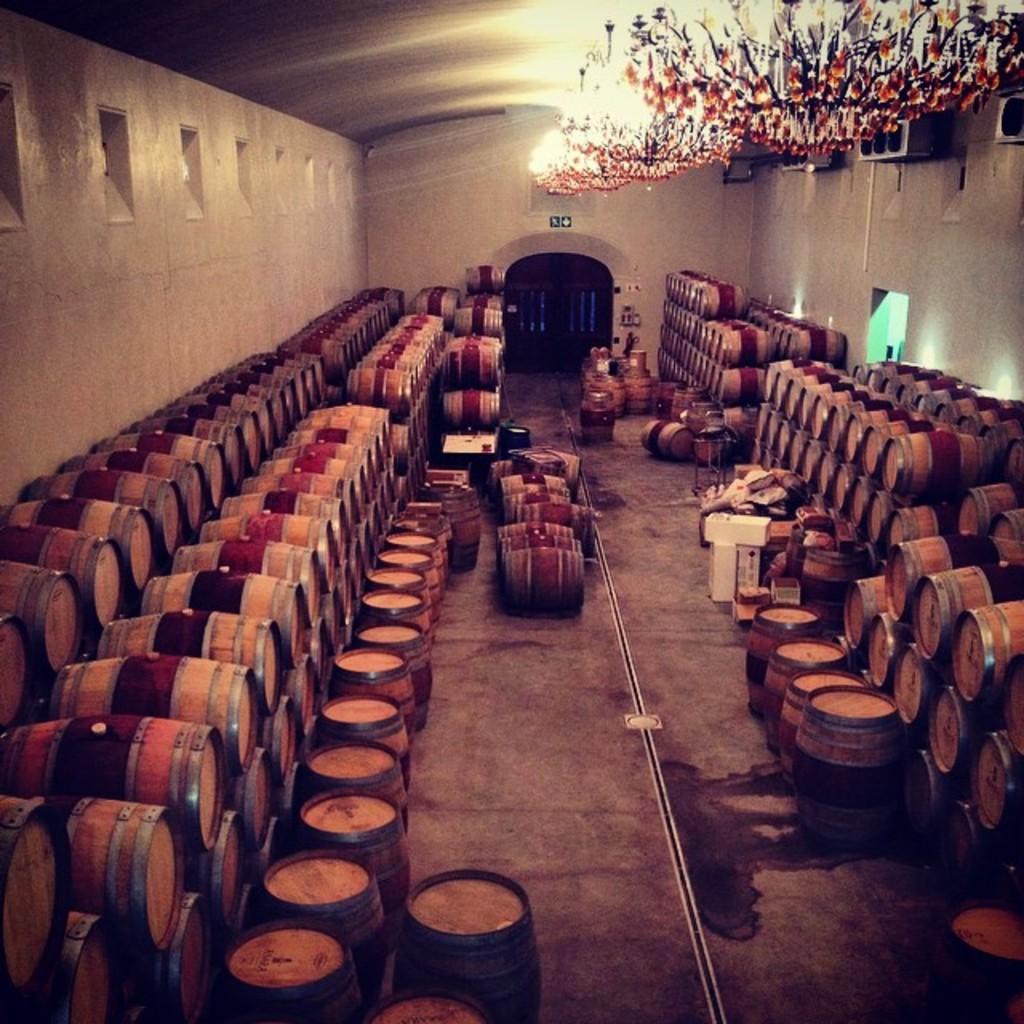Please provide a concise description of this image. In this image I can see group of wooden barrels placed in and order. I can see a white color object here. These are the lights attached to the rooftop. I can see and object which is attached to the wall. This is the floor. I think these are the windows. This looks like a godown(warehouse). 